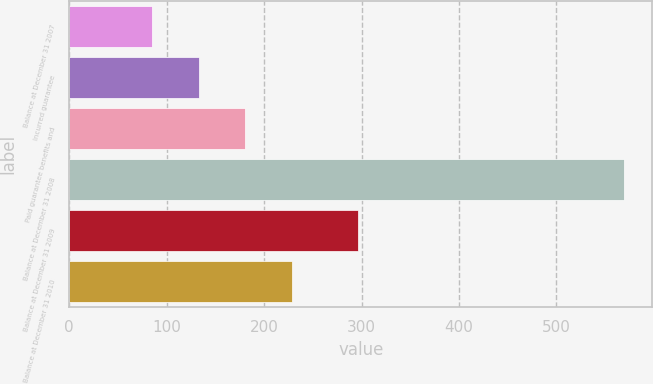Convert chart. <chart><loc_0><loc_0><loc_500><loc_500><bar_chart><fcel>Balance at December 31 2007<fcel>Incurred guarantee<fcel>Paid guarantee benefits and<fcel>Balance at December 31 2008<fcel>Balance at December 31 2009<fcel>Balance at December 31 2010<nl><fcel>85<fcel>132.8<fcel>180.6<fcel>569.8<fcel>296<fcel>228.4<nl></chart> 